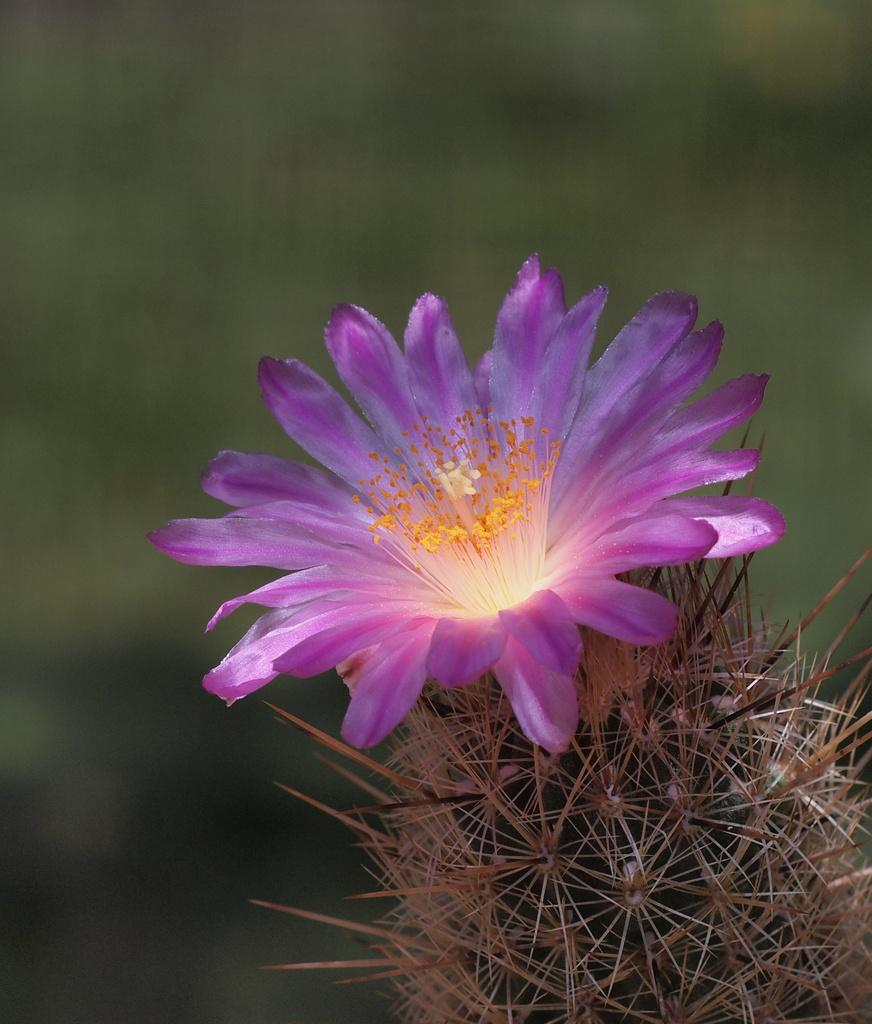What is the main subject of the image? The main subject of the image is a plant. What specific feature can be observed on the plant? The plant has a flower. How would you describe the background of the image? The background of the image is blurry. How many offices can be seen in the background of the image? There are no offices visible in the image; it features a plant with a flower and a blurry background. 